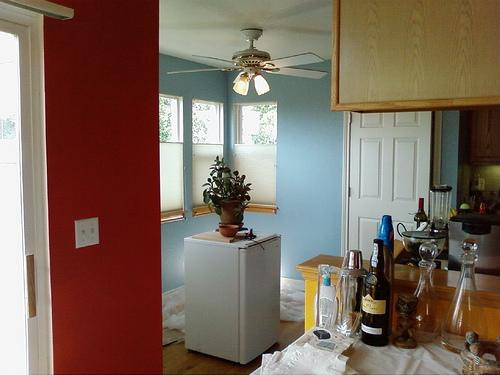What is the plant sitting on? Please explain your reasoning. refrigerator. There is a potted plant on the fridge. 